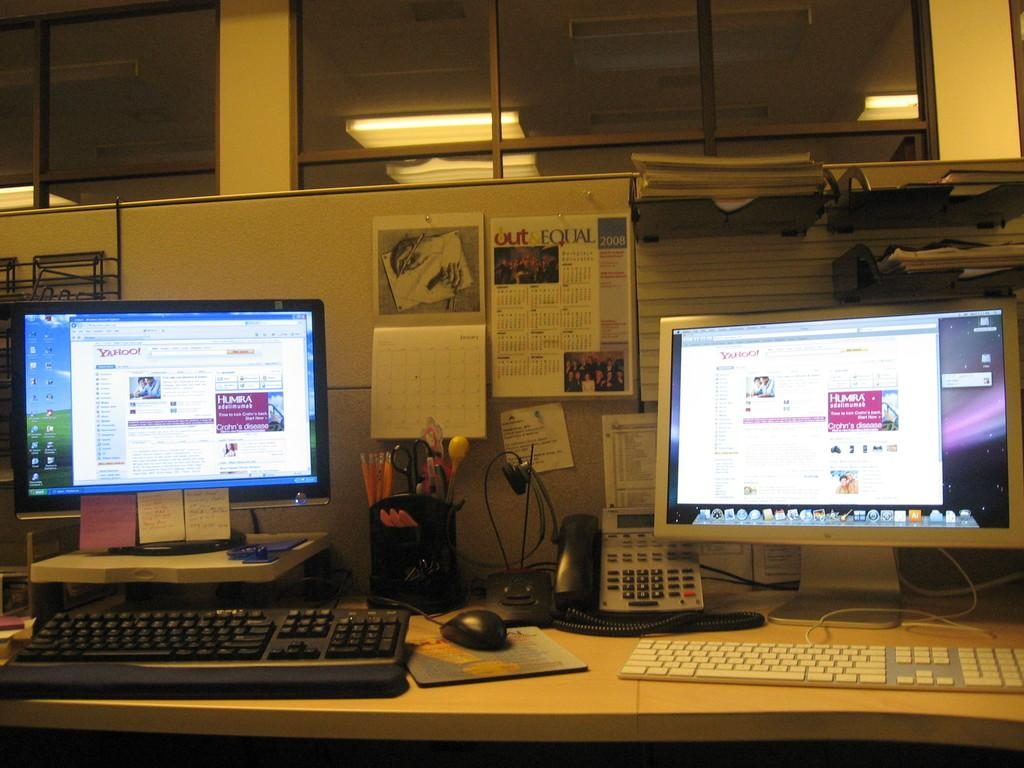Provide a one-sentence caption for the provided image. Two computer's sit on top of an office desk  with a 2008 calender in the background called Out and Equal. 